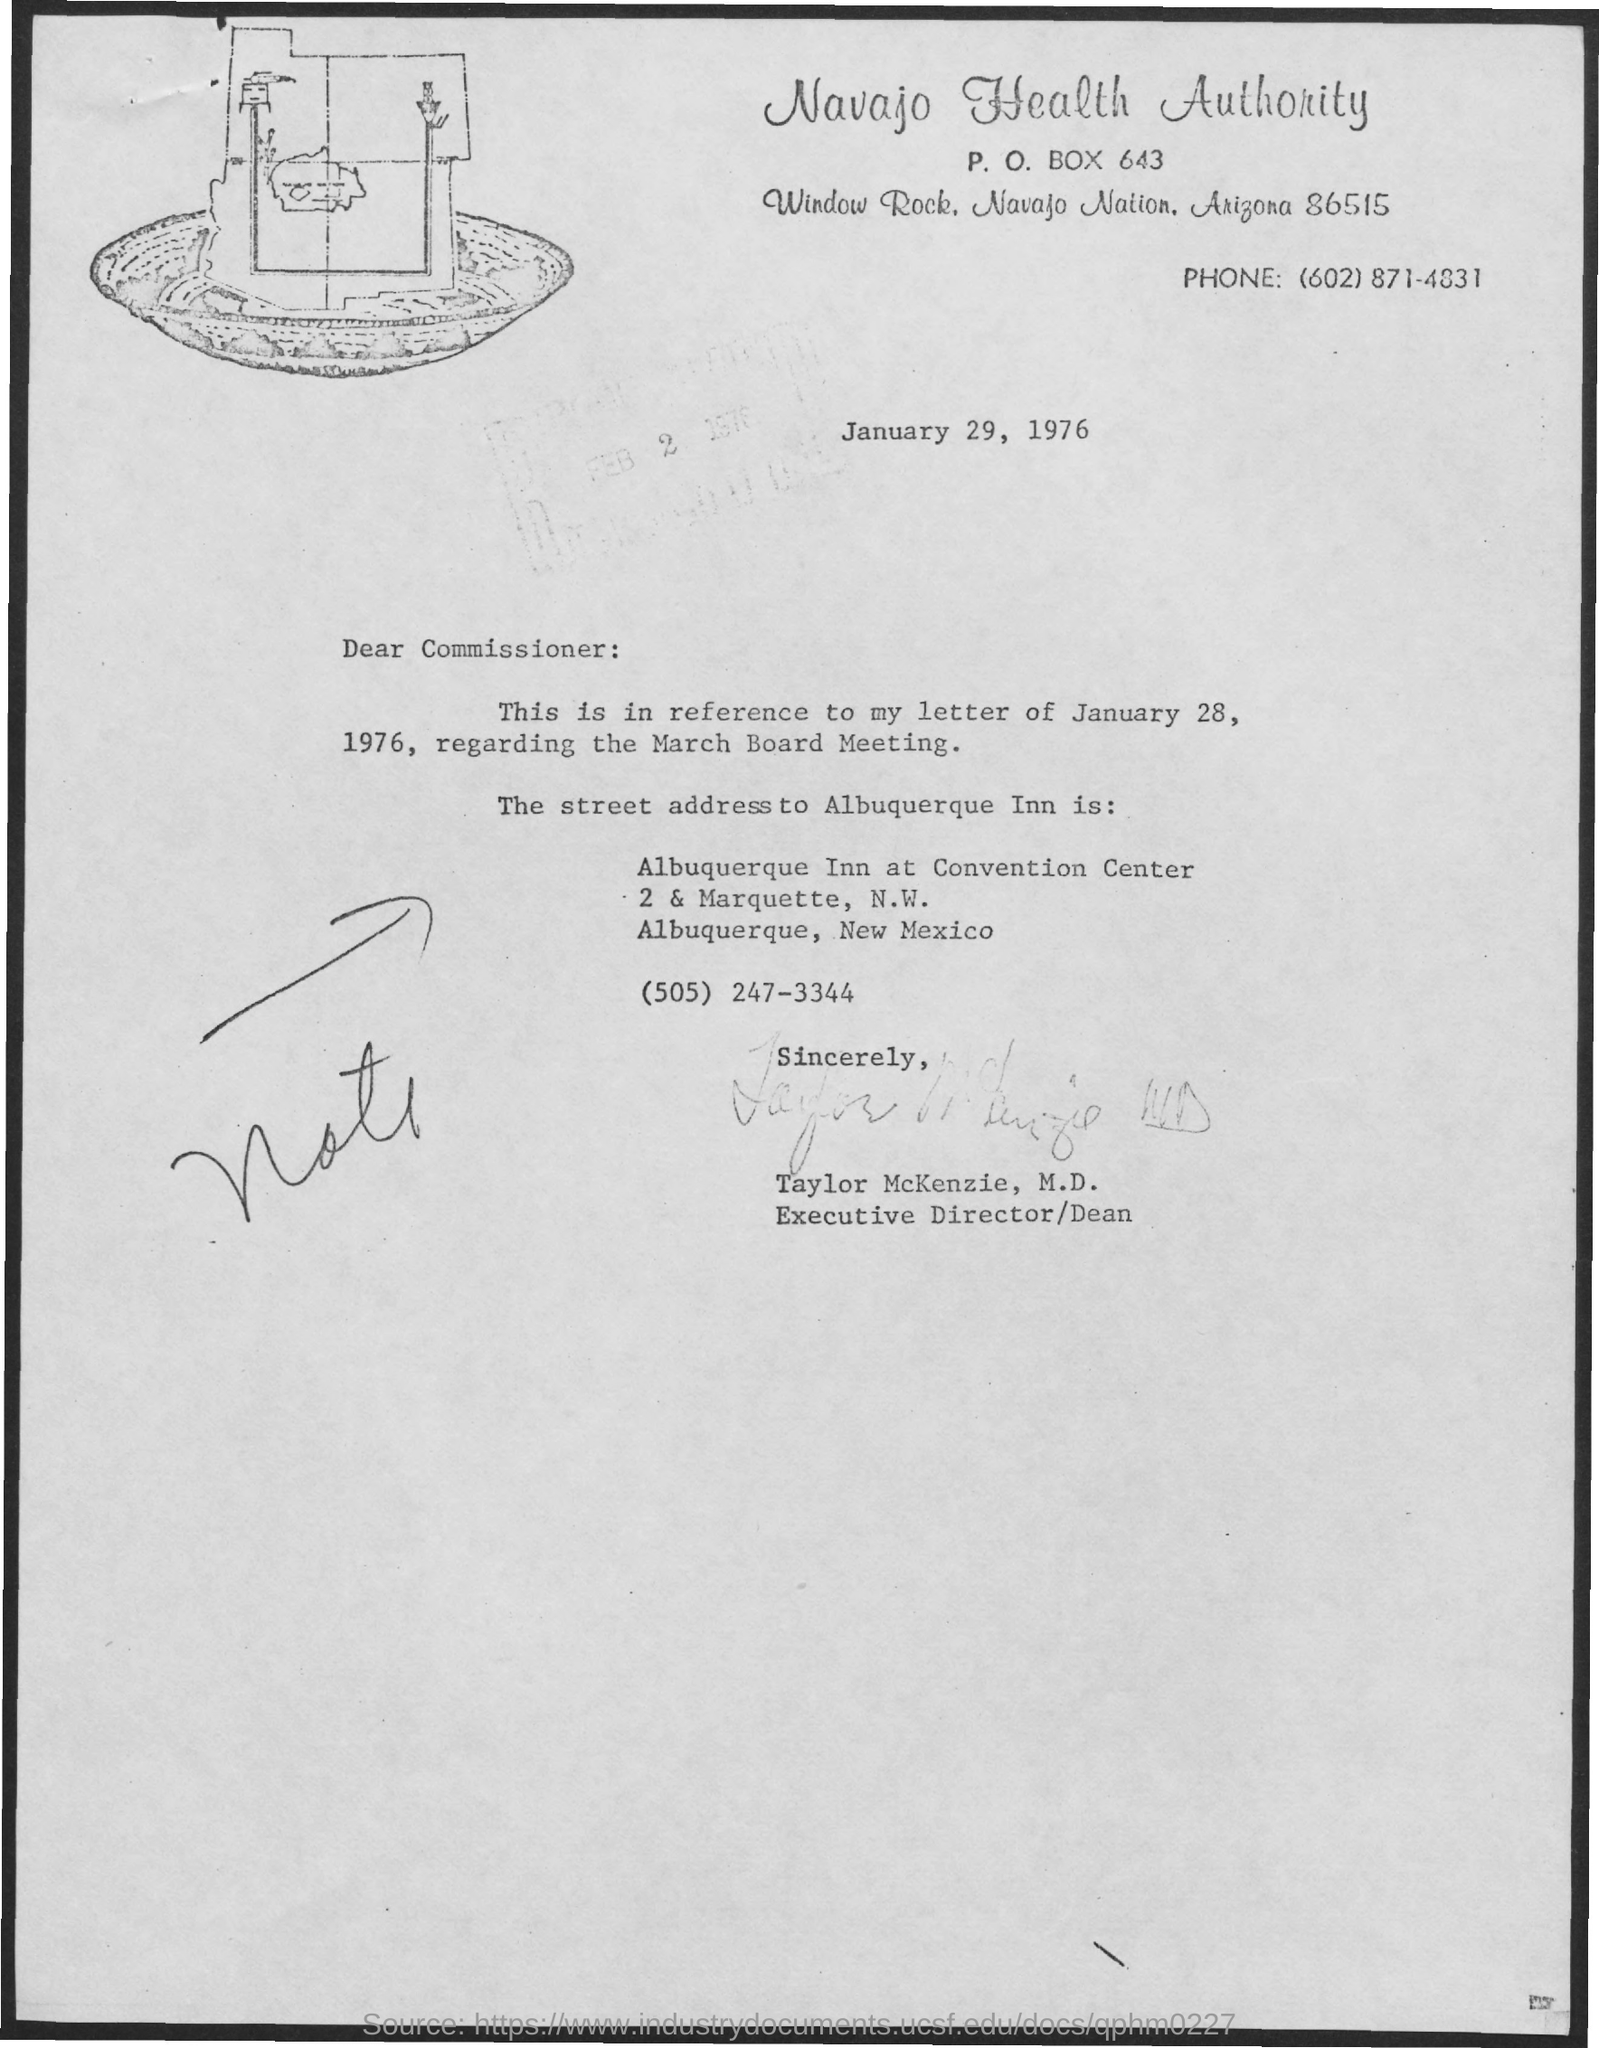What is the p.o. box no. mentioned ?
Offer a terse response. P. O. BOX 643. Who's sign was there at the bottom of the letter ?
Make the answer very short. Taylor McKenzie. 